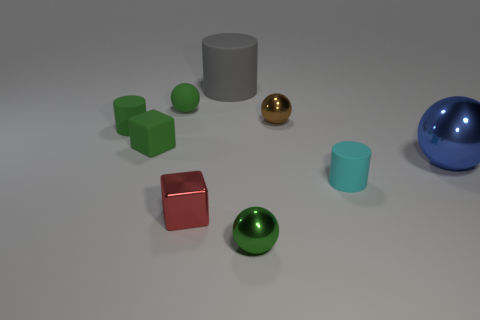Subtract all green cylinders. How many green spheres are left? 2 Subtract 1 balls. How many balls are left? 3 Subtract all blue spheres. How many spheres are left? 3 Subtract all large balls. How many balls are left? 3 Subtract all red spheres. Subtract all cyan cylinders. How many spheres are left? 4 Subtract all cylinders. How many objects are left? 6 Add 8 large blue objects. How many large blue objects are left? 9 Add 9 tiny gray matte cubes. How many tiny gray matte cubes exist? 9 Subtract 1 red blocks. How many objects are left? 8 Subtract all small blue shiny objects. Subtract all tiny cyan things. How many objects are left? 8 